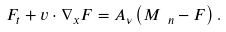Convert formula to latex. <formula><loc_0><loc_0><loc_500><loc_500>F _ { t } + v \cdot \nabla _ { x } F = A _ { \nu } \left ( M _ { \ n } - F \right ) .</formula> 